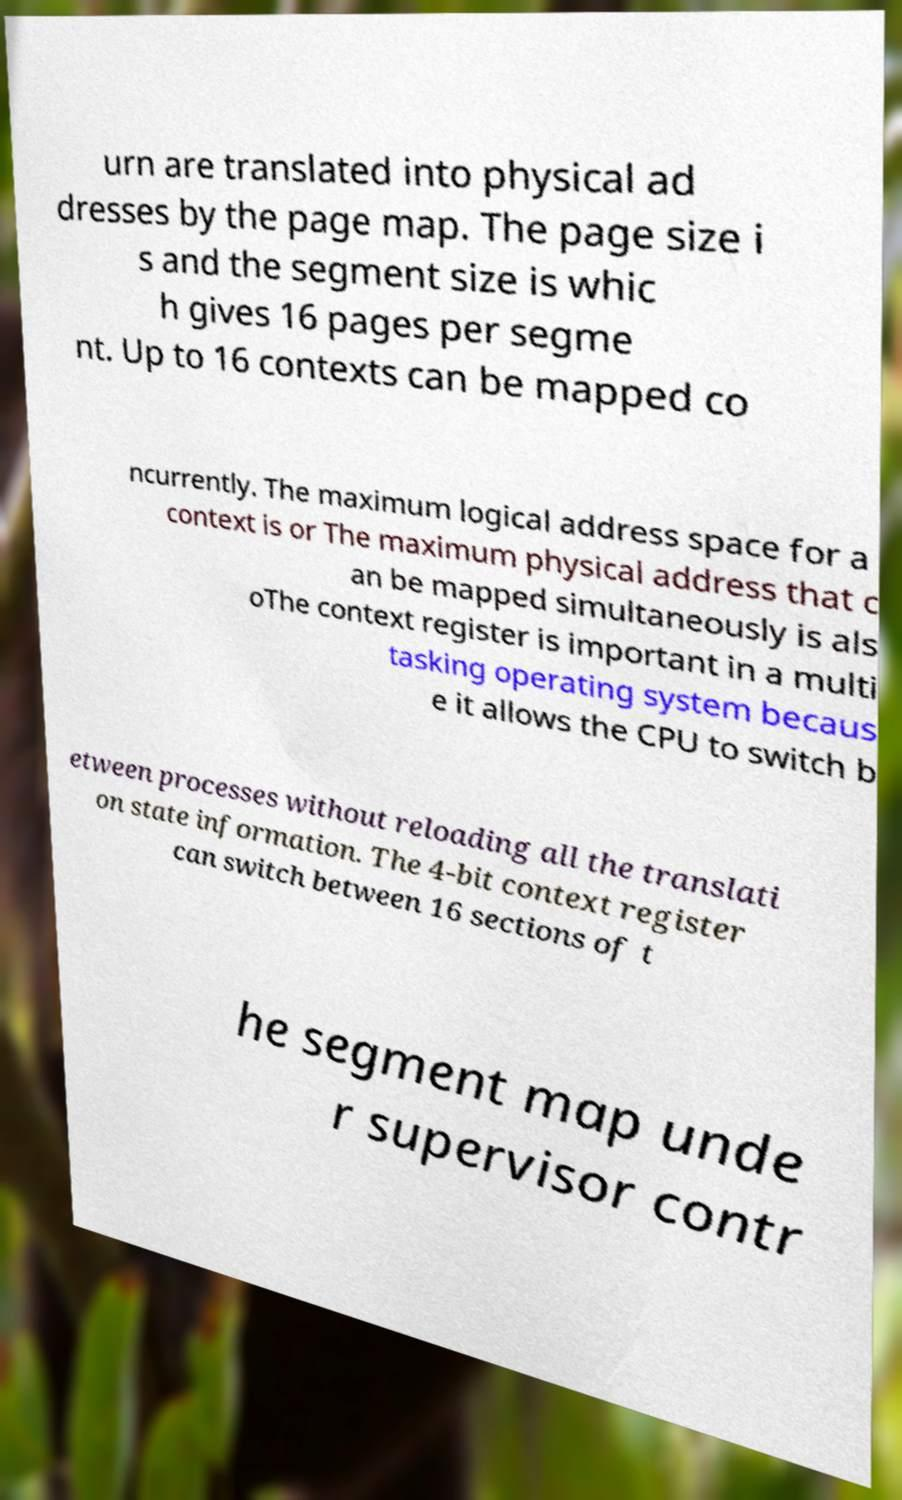Please read and relay the text visible in this image. What does it say? urn are translated into physical ad dresses by the page map. The page size i s and the segment size is whic h gives 16 pages per segme nt. Up to 16 contexts can be mapped co ncurrently. The maximum logical address space for a context is or The maximum physical address that c an be mapped simultaneously is als oThe context register is important in a multi tasking operating system becaus e it allows the CPU to switch b etween processes without reloading all the translati on state information. The 4-bit context register can switch between 16 sections of t he segment map unde r supervisor contr 